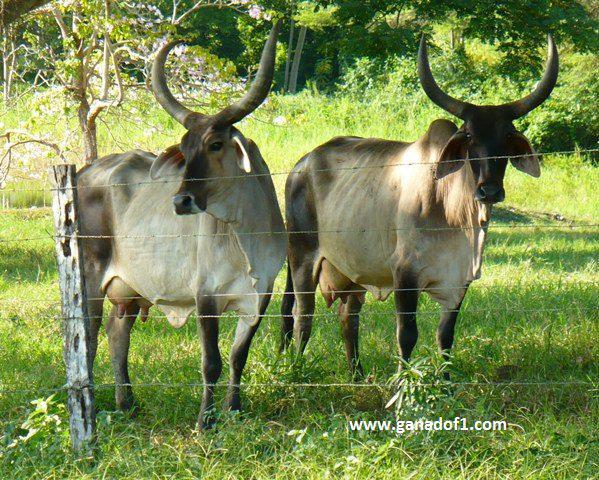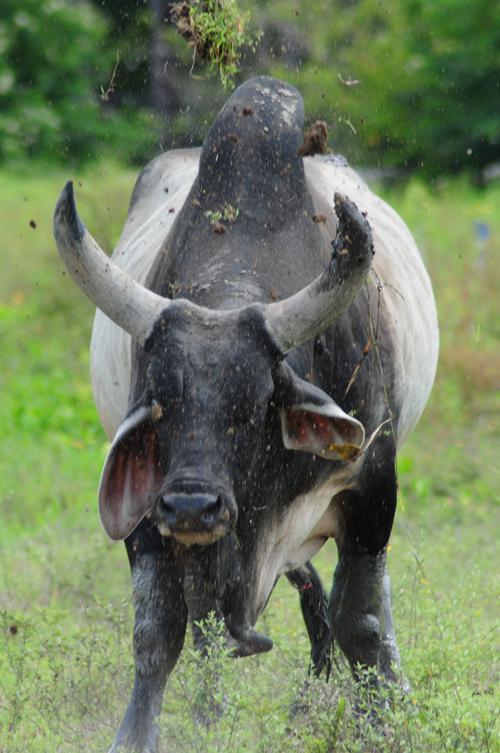The first image is the image on the left, the second image is the image on the right. Considering the images on both sides, is "One of the animals is wearing decorations." valid? Answer yes or no. No. The first image is the image on the left, the second image is the image on the right. Examine the images to the left and right. Is the description "The right image contains one forward-facing ox with a somewhat lowered head, and the left image shows two look-alike oxen standing on green grass." accurate? Answer yes or no. Yes. 